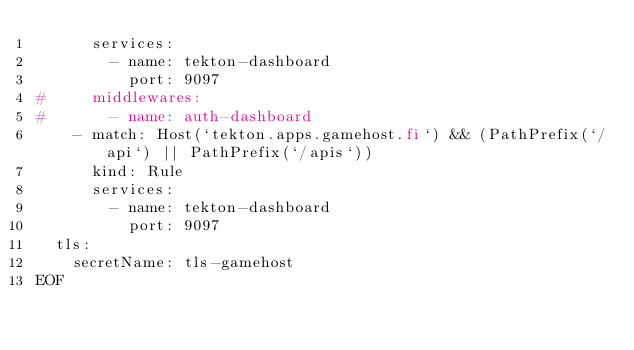<code> <loc_0><loc_0><loc_500><loc_500><_Bash_>      services:
        - name: tekton-dashboard
          port: 9097
#     middlewares:
#       - name: auth-dashboard
    - match: Host(`tekton.apps.gamehost.fi`) && (PathPrefix(`/api`) || PathPrefix(`/apis`))
      kind: Rule
      services:
        - name: tekton-dashboard
          port: 9097
  tls:
    secretName: tls-gamehost
EOF
</code> 